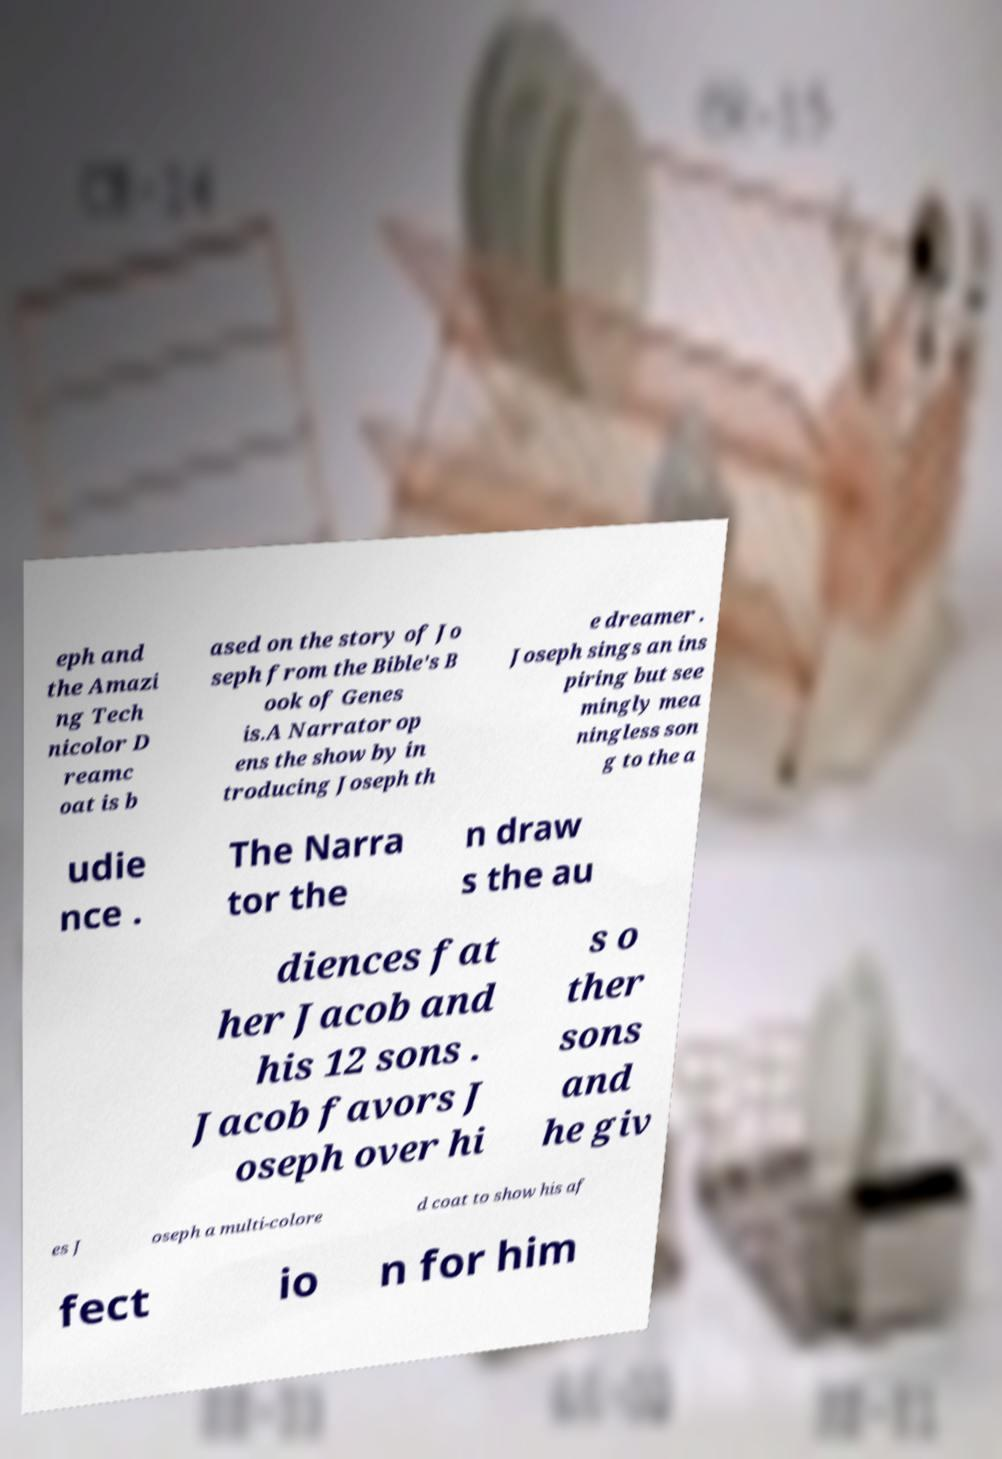I need the written content from this picture converted into text. Can you do that? eph and the Amazi ng Tech nicolor D reamc oat is b ased on the story of Jo seph from the Bible's B ook of Genes is.A Narrator op ens the show by in troducing Joseph th e dreamer . Joseph sings an ins piring but see mingly mea ningless son g to the a udie nce . The Narra tor the n draw s the au diences fat her Jacob and his 12 sons . Jacob favors J oseph over hi s o ther sons and he giv es J oseph a multi-colore d coat to show his af fect io n for him 